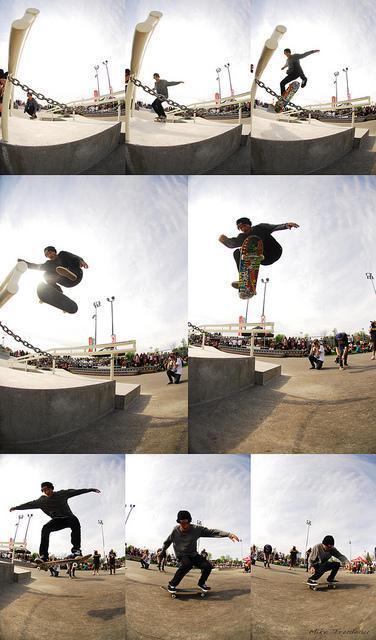How many shots do you see in the college?
Give a very brief answer. 8. How many people are there?
Give a very brief answer. 3. How many knives are on the wall?
Give a very brief answer. 0. 